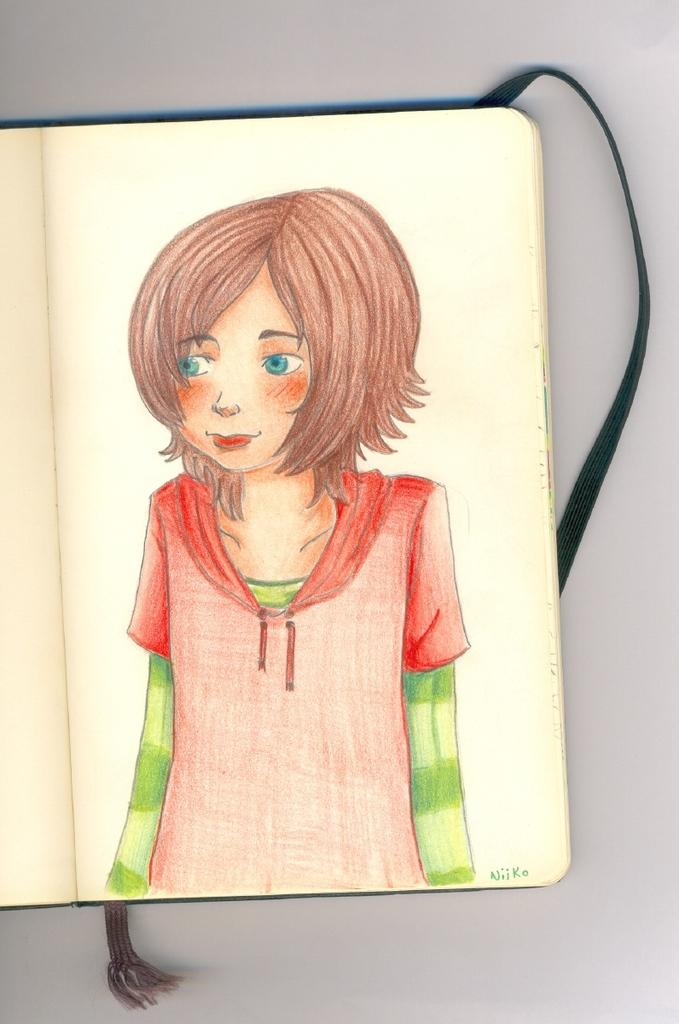What is depicted in the painting that is visible in the image? There is a painting of a girl in the image. Where is the painting located? The painting is on a book. What is the book resting on? The book is on a table. How many boats are featured in the painting? There are no boats present in the painting or the image. 